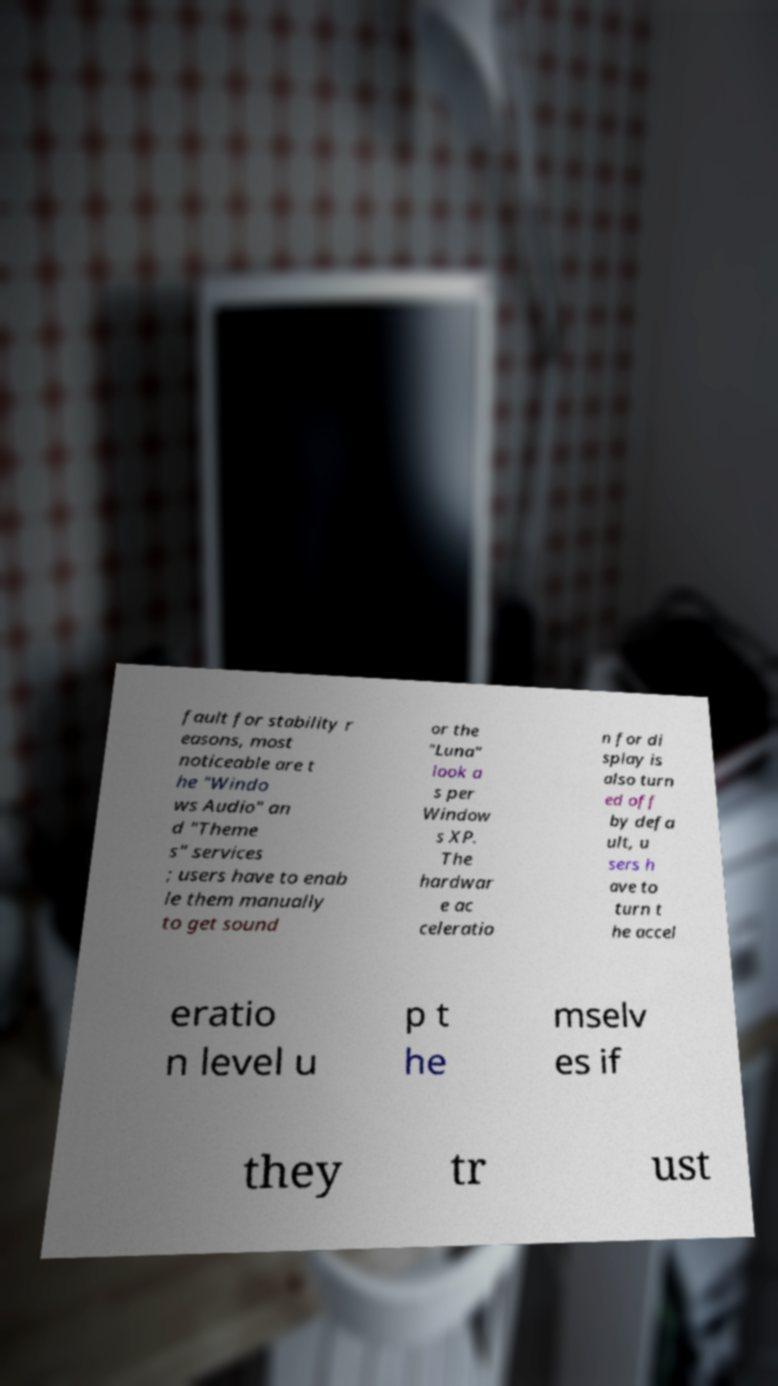Please read and relay the text visible in this image. What does it say? fault for stability r easons, most noticeable are t he "Windo ws Audio" an d "Theme s" services ; users have to enab le them manually to get sound or the "Luna" look a s per Window s XP. The hardwar e ac celeratio n for di splay is also turn ed off by defa ult, u sers h ave to turn t he accel eratio n level u p t he mselv es if they tr ust 